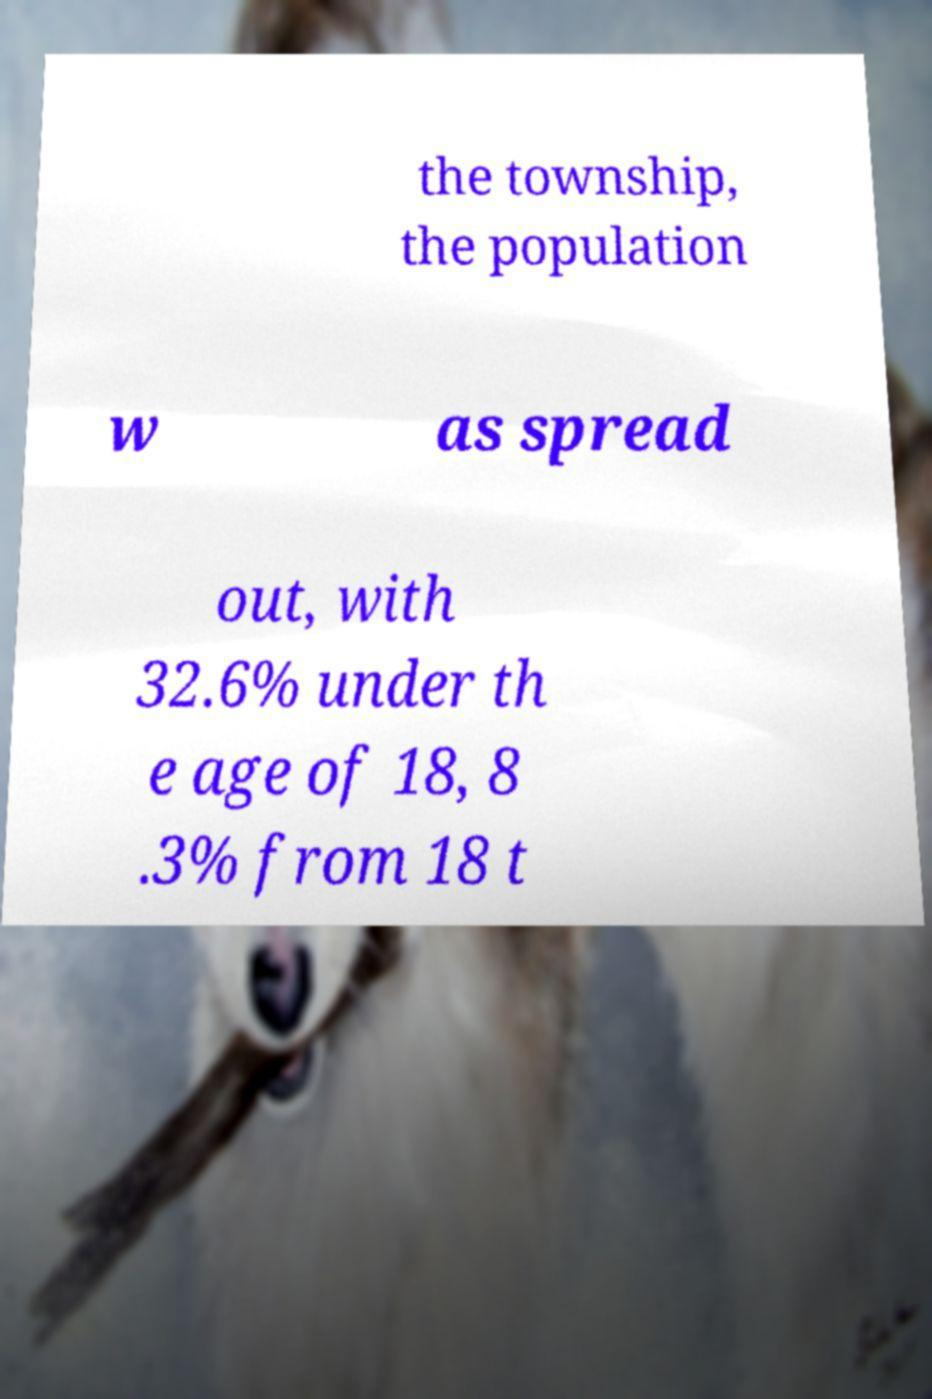Please read and relay the text visible in this image. What does it say? the township, the population w as spread out, with 32.6% under th e age of 18, 8 .3% from 18 t 